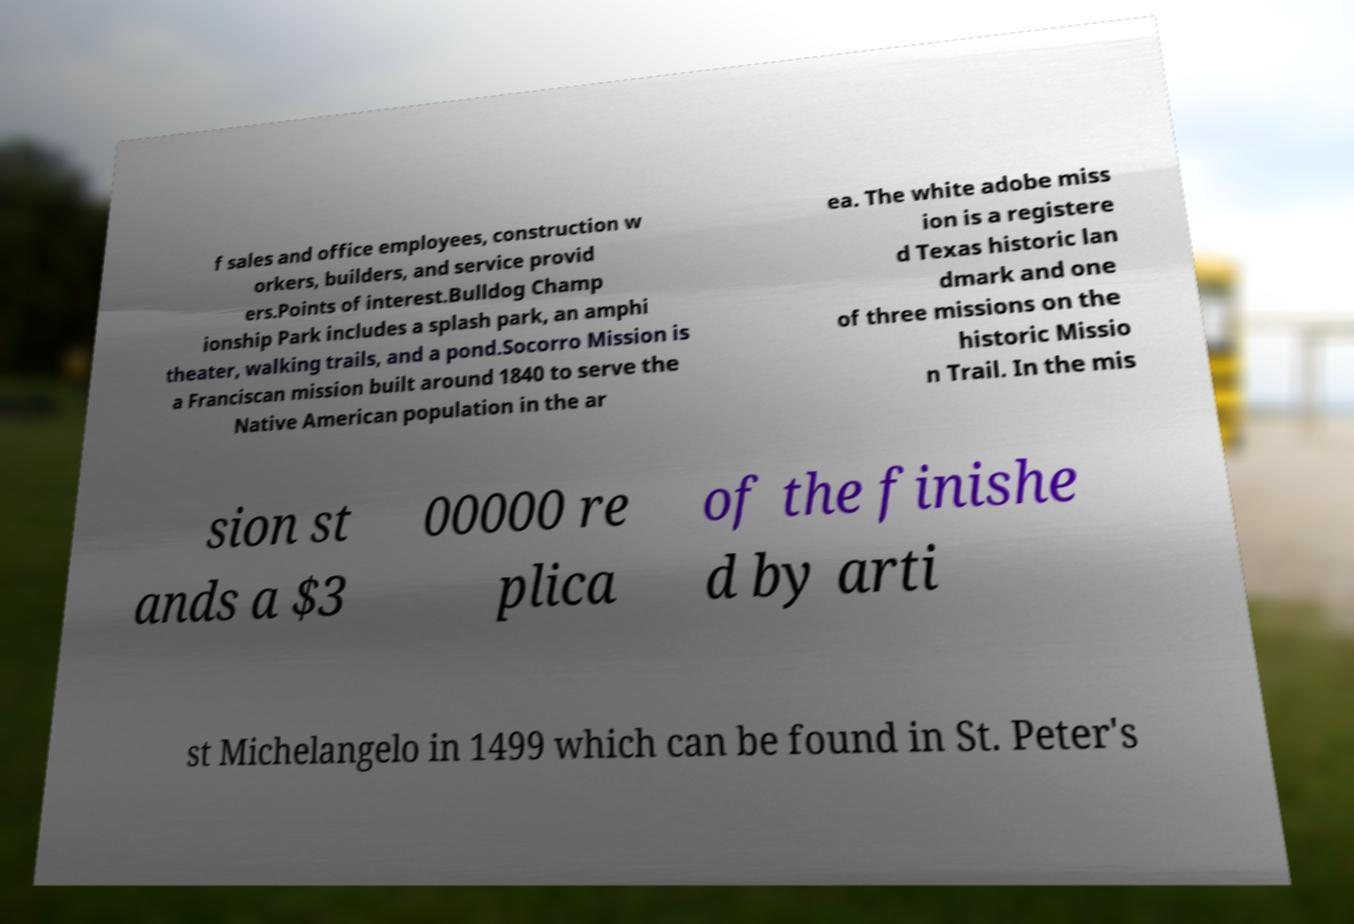Can you read and provide the text displayed in the image?This photo seems to have some interesting text. Can you extract and type it out for me? f sales and office employees, construction w orkers, builders, and service provid ers.Points of interest.Bulldog Champ ionship Park includes a splash park, an amphi theater, walking trails, and a pond.Socorro Mission is a Franciscan mission built around 1840 to serve the Native American population in the ar ea. The white adobe miss ion is a registere d Texas historic lan dmark and one of three missions on the historic Missio n Trail. In the mis sion st ands a $3 00000 re plica of the finishe d by arti st Michelangelo in 1499 which can be found in St. Peter's 